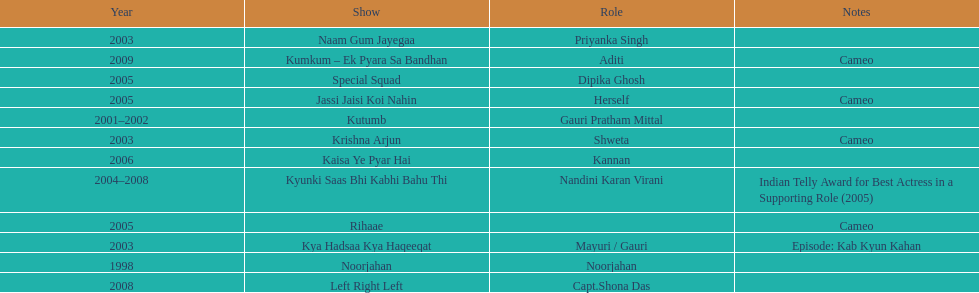What shows did gauri pradhan tejwani star in? Noorjahan, Kutumb, Krishna Arjun, Naam Gum Jayegaa, Kya Hadsaa Kya Haqeeqat, Kyunki Saas Bhi Kabhi Bahu Thi, Rihaae, Jassi Jaisi Koi Nahin, Special Squad, Kaisa Ye Pyar Hai, Left Right Left, Kumkum – Ek Pyara Sa Bandhan. Of these, which were cameos? Krishna Arjun, Rihaae, Jassi Jaisi Koi Nahin, Kumkum – Ek Pyara Sa Bandhan. Of these, in which did she play the role of herself? Jassi Jaisi Koi Nahin. 